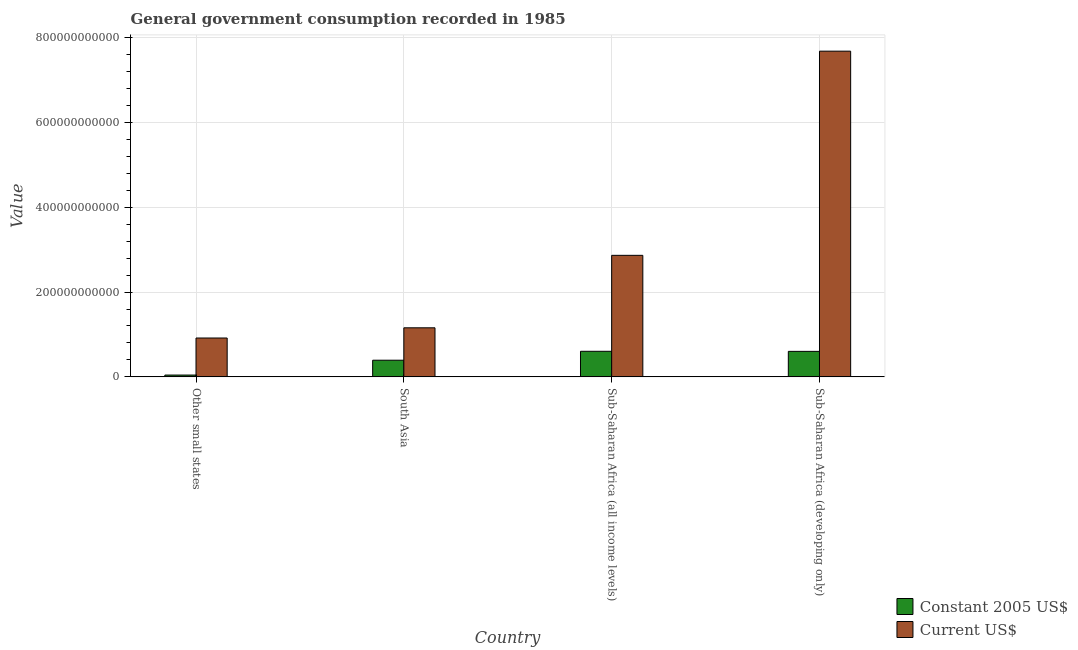Are the number of bars per tick equal to the number of legend labels?
Your answer should be very brief. Yes. Are the number of bars on each tick of the X-axis equal?
Offer a very short reply. Yes. How many bars are there on the 1st tick from the left?
Provide a succinct answer. 2. What is the label of the 4th group of bars from the left?
Your response must be concise. Sub-Saharan Africa (developing only). What is the value consumed in constant 2005 us$ in Other small states?
Your answer should be compact. 4.27e+09. Across all countries, what is the maximum value consumed in constant 2005 us$?
Provide a succinct answer. 6.03e+1. Across all countries, what is the minimum value consumed in current us$?
Make the answer very short. 9.16e+1. In which country was the value consumed in current us$ maximum?
Offer a terse response. Sub-Saharan Africa (developing only). In which country was the value consumed in constant 2005 us$ minimum?
Your response must be concise. Other small states. What is the total value consumed in current us$ in the graph?
Your answer should be compact. 1.26e+12. What is the difference between the value consumed in constant 2005 us$ in Sub-Saharan Africa (all income levels) and that in Sub-Saharan Africa (developing only)?
Give a very brief answer. 1.81e+08. What is the difference between the value consumed in current us$ in Sub-Saharan Africa (all income levels) and the value consumed in constant 2005 us$ in Sub-Saharan Africa (developing only)?
Your response must be concise. 2.26e+11. What is the average value consumed in constant 2005 us$ per country?
Make the answer very short. 4.10e+1. What is the difference between the value consumed in constant 2005 us$ and value consumed in current us$ in South Asia?
Provide a short and direct response. -7.64e+1. In how many countries, is the value consumed in constant 2005 us$ greater than 560000000000 ?
Offer a terse response. 0. What is the ratio of the value consumed in constant 2005 us$ in Other small states to that in South Asia?
Your answer should be very brief. 0.11. Is the value consumed in constant 2005 us$ in South Asia less than that in Sub-Saharan Africa (developing only)?
Make the answer very short. Yes. Is the difference between the value consumed in constant 2005 us$ in South Asia and Sub-Saharan Africa (all income levels) greater than the difference between the value consumed in current us$ in South Asia and Sub-Saharan Africa (all income levels)?
Offer a terse response. Yes. What is the difference between the highest and the second highest value consumed in current us$?
Your answer should be compact. 4.81e+11. What is the difference between the highest and the lowest value consumed in constant 2005 us$?
Your answer should be compact. 5.61e+1. What does the 2nd bar from the left in Sub-Saharan Africa (all income levels) represents?
Keep it short and to the point. Current US$. What does the 2nd bar from the right in South Asia represents?
Make the answer very short. Constant 2005 US$. How many countries are there in the graph?
Your response must be concise. 4. What is the difference between two consecutive major ticks on the Y-axis?
Provide a succinct answer. 2.00e+11. Are the values on the major ticks of Y-axis written in scientific E-notation?
Make the answer very short. No. Does the graph contain grids?
Your response must be concise. Yes. What is the title of the graph?
Your answer should be compact. General government consumption recorded in 1985. What is the label or title of the X-axis?
Offer a very short reply. Country. What is the label or title of the Y-axis?
Offer a terse response. Value. What is the Value of Constant 2005 US$ in Other small states?
Your answer should be compact. 4.27e+09. What is the Value in Current US$ in Other small states?
Your answer should be very brief. 9.16e+1. What is the Value of Constant 2005 US$ in South Asia?
Keep it short and to the point. 3.93e+1. What is the Value of Current US$ in South Asia?
Offer a very short reply. 1.16e+11. What is the Value in Constant 2005 US$ in Sub-Saharan Africa (all income levels)?
Your answer should be compact. 6.03e+1. What is the Value in Current US$ in Sub-Saharan Africa (all income levels)?
Your response must be concise. 2.87e+11. What is the Value in Constant 2005 US$ in Sub-Saharan Africa (developing only)?
Give a very brief answer. 6.01e+1. What is the Value of Current US$ in Sub-Saharan Africa (developing only)?
Your response must be concise. 7.68e+11. Across all countries, what is the maximum Value in Constant 2005 US$?
Your answer should be compact. 6.03e+1. Across all countries, what is the maximum Value of Current US$?
Give a very brief answer. 7.68e+11. Across all countries, what is the minimum Value of Constant 2005 US$?
Your response must be concise. 4.27e+09. Across all countries, what is the minimum Value in Current US$?
Your response must be concise. 9.16e+1. What is the total Value in Constant 2005 US$ in the graph?
Ensure brevity in your answer.  1.64e+11. What is the total Value in Current US$ in the graph?
Offer a terse response. 1.26e+12. What is the difference between the Value of Constant 2005 US$ in Other small states and that in South Asia?
Provide a short and direct response. -3.50e+1. What is the difference between the Value of Current US$ in Other small states and that in South Asia?
Your answer should be very brief. -2.41e+1. What is the difference between the Value of Constant 2005 US$ in Other small states and that in Sub-Saharan Africa (all income levels)?
Keep it short and to the point. -5.61e+1. What is the difference between the Value in Current US$ in Other small states and that in Sub-Saharan Africa (all income levels)?
Your answer should be very brief. -1.95e+11. What is the difference between the Value of Constant 2005 US$ in Other small states and that in Sub-Saharan Africa (developing only)?
Keep it short and to the point. -5.59e+1. What is the difference between the Value of Current US$ in Other small states and that in Sub-Saharan Africa (developing only)?
Offer a terse response. -6.76e+11. What is the difference between the Value of Constant 2005 US$ in South Asia and that in Sub-Saharan Africa (all income levels)?
Offer a terse response. -2.11e+1. What is the difference between the Value in Current US$ in South Asia and that in Sub-Saharan Africa (all income levels)?
Your answer should be very brief. -1.71e+11. What is the difference between the Value in Constant 2005 US$ in South Asia and that in Sub-Saharan Africa (developing only)?
Ensure brevity in your answer.  -2.09e+1. What is the difference between the Value of Current US$ in South Asia and that in Sub-Saharan Africa (developing only)?
Give a very brief answer. -6.52e+11. What is the difference between the Value of Constant 2005 US$ in Sub-Saharan Africa (all income levels) and that in Sub-Saharan Africa (developing only)?
Your answer should be very brief. 1.81e+08. What is the difference between the Value of Current US$ in Sub-Saharan Africa (all income levels) and that in Sub-Saharan Africa (developing only)?
Your response must be concise. -4.81e+11. What is the difference between the Value of Constant 2005 US$ in Other small states and the Value of Current US$ in South Asia?
Keep it short and to the point. -1.11e+11. What is the difference between the Value of Constant 2005 US$ in Other small states and the Value of Current US$ in Sub-Saharan Africa (all income levels)?
Offer a terse response. -2.82e+11. What is the difference between the Value of Constant 2005 US$ in Other small states and the Value of Current US$ in Sub-Saharan Africa (developing only)?
Your answer should be very brief. -7.64e+11. What is the difference between the Value in Constant 2005 US$ in South Asia and the Value in Current US$ in Sub-Saharan Africa (all income levels)?
Offer a terse response. -2.47e+11. What is the difference between the Value in Constant 2005 US$ in South Asia and the Value in Current US$ in Sub-Saharan Africa (developing only)?
Ensure brevity in your answer.  -7.29e+11. What is the difference between the Value in Constant 2005 US$ in Sub-Saharan Africa (all income levels) and the Value in Current US$ in Sub-Saharan Africa (developing only)?
Your answer should be very brief. -7.08e+11. What is the average Value in Constant 2005 US$ per country?
Provide a short and direct response. 4.10e+1. What is the average Value of Current US$ per country?
Offer a very short reply. 3.15e+11. What is the difference between the Value in Constant 2005 US$ and Value in Current US$ in Other small states?
Provide a succinct answer. -8.74e+1. What is the difference between the Value in Constant 2005 US$ and Value in Current US$ in South Asia?
Your answer should be compact. -7.64e+1. What is the difference between the Value in Constant 2005 US$ and Value in Current US$ in Sub-Saharan Africa (all income levels)?
Offer a terse response. -2.26e+11. What is the difference between the Value of Constant 2005 US$ and Value of Current US$ in Sub-Saharan Africa (developing only)?
Your answer should be very brief. -7.08e+11. What is the ratio of the Value of Constant 2005 US$ in Other small states to that in South Asia?
Offer a terse response. 0.11. What is the ratio of the Value of Current US$ in Other small states to that in South Asia?
Make the answer very short. 0.79. What is the ratio of the Value of Constant 2005 US$ in Other small states to that in Sub-Saharan Africa (all income levels)?
Provide a short and direct response. 0.07. What is the ratio of the Value in Current US$ in Other small states to that in Sub-Saharan Africa (all income levels)?
Your answer should be compact. 0.32. What is the ratio of the Value in Constant 2005 US$ in Other small states to that in Sub-Saharan Africa (developing only)?
Ensure brevity in your answer.  0.07. What is the ratio of the Value of Current US$ in Other small states to that in Sub-Saharan Africa (developing only)?
Provide a succinct answer. 0.12. What is the ratio of the Value in Constant 2005 US$ in South Asia to that in Sub-Saharan Africa (all income levels)?
Your answer should be compact. 0.65. What is the ratio of the Value of Current US$ in South Asia to that in Sub-Saharan Africa (all income levels)?
Ensure brevity in your answer.  0.4. What is the ratio of the Value in Constant 2005 US$ in South Asia to that in Sub-Saharan Africa (developing only)?
Your answer should be very brief. 0.65. What is the ratio of the Value of Current US$ in South Asia to that in Sub-Saharan Africa (developing only)?
Provide a succinct answer. 0.15. What is the ratio of the Value in Current US$ in Sub-Saharan Africa (all income levels) to that in Sub-Saharan Africa (developing only)?
Your answer should be very brief. 0.37. What is the difference between the highest and the second highest Value of Constant 2005 US$?
Offer a terse response. 1.81e+08. What is the difference between the highest and the second highest Value of Current US$?
Keep it short and to the point. 4.81e+11. What is the difference between the highest and the lowest Value of Constant 2005 US$?
Ensure brevity in your answer.  5.61e+1. What is the difference between the highest and the lowest Value in Current US$?
Make the answer very short. 6.76e+11. 